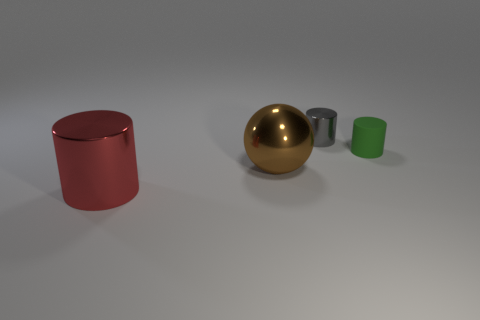Add 3 red cylinders. How many objects exist? 7 Subtract all balls. How many objects are left? 3 Add 3 green rubber objects. How many green rubber objects are left? 4 Add 3 matte spheres. How many matte spheres exist? 3 Subtract 0 gray cubes. How many objects are left? 4 Subtract all tiny metallic cylinders. Subtract all small green cylinders. How many objects are left? 2 